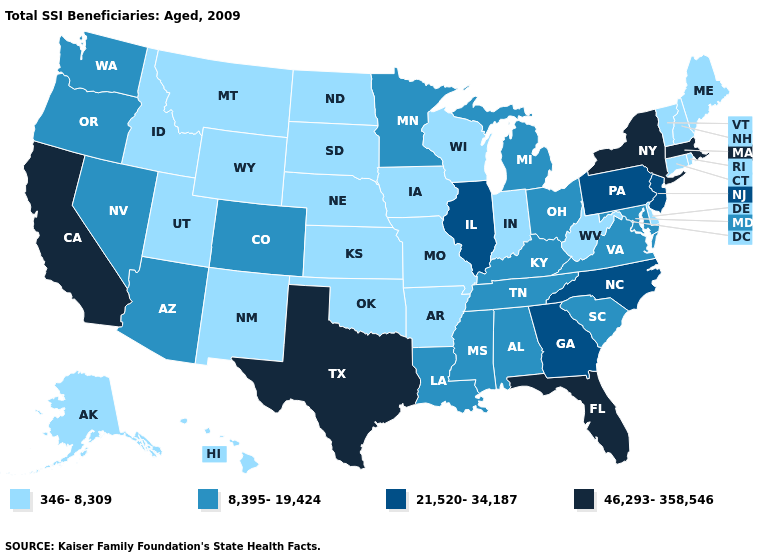Name the states that have a value in the range 46,293-358,546?
Concise answer only. California, Florida, Massachusetts, New York, Texas. Which states have the highest value in the USA?
Concise answer only. California, Florida, Massachusetts, New York, Texas. Does New York have the highest value in the USA?
Quick response, please. Yes. Does Minnesota have the lowest value in the MidWest?
Answer briefly. No. What is the lowest value in states that border Wyoming?
Concise answer only. 346-8,309. Name the states that have a value in the range 21,520-34,187?
Be succinct. Georgia, Illinois, New Jersey, North Carolina, Pennsylvania. Name the states that have a value in the range 21,520-34,187?
Quick response, please. Georgia, Illinois, New Jersey, North Carolina, Pennsylvania. Name the states that have a value in the range 46,293-358,546?
Give a very brief answer. California, Florida, Massachusetts, New York, Texas. Among the states that border North Carolina , which have the lowest value?
Concise answer only. South Carolina, Tennessee, Virginia. What is the lowest value in the USA?
Keep it brief. 346-8,309. Which states hav the highest value in the South?
Write a very short answer. Florida, Texas. Is the legend a continuous bar?
Quick response, please. No. What is the value of Minnesota?
Quick response, please. 8,395-19,424. Is the legend a continuous bar?
Short answer required. No. Name the states that have a value in the range 46,293-358,546?
Quick response, please. California, Florida, Massachusetts, New York, Texas. 